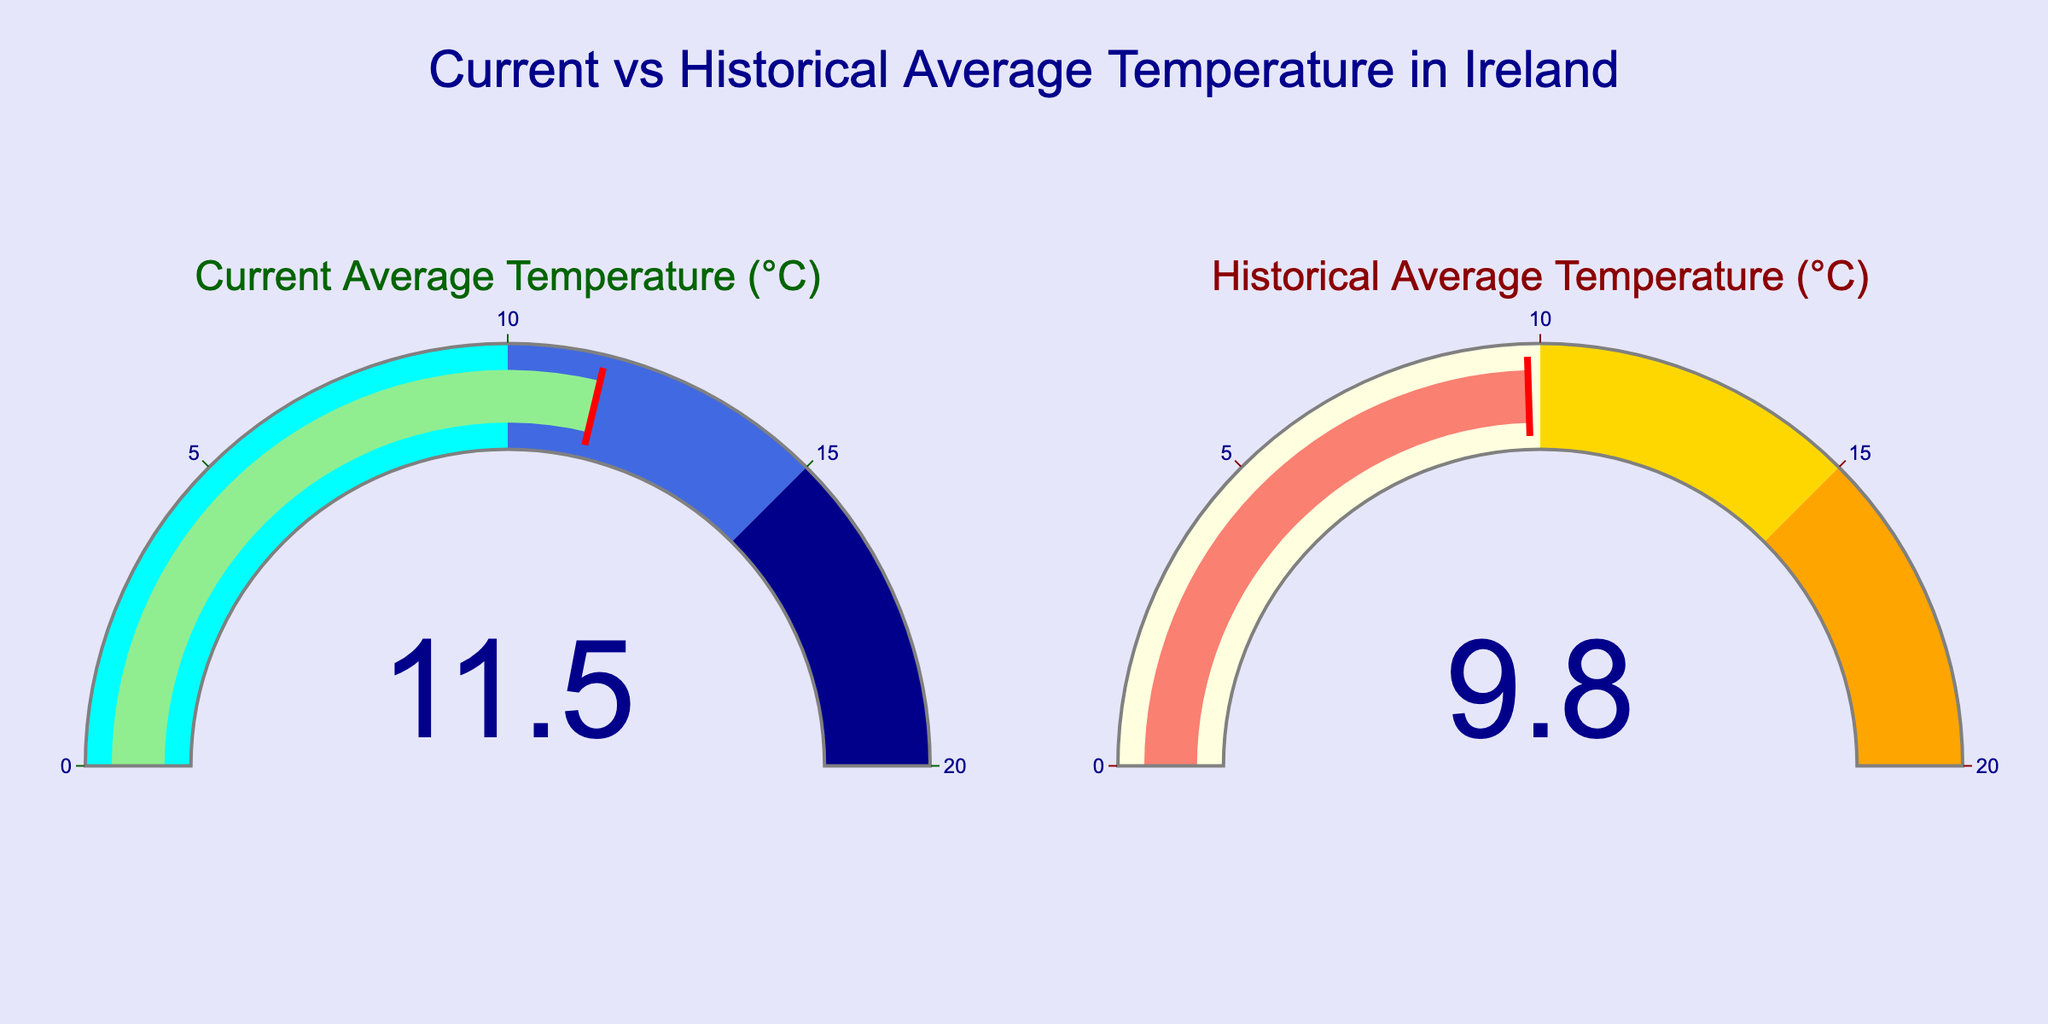How much higher is the current average temperature compared to the historical average temperature? Subtract the historical average temperature (9.8°C) from the current average temperature (11.5°C): 11.5 - 9.8 = 1.7°C.
Answer: 1.7°C What is the title of the figure? Read the title located at the top-center of the figure: "Current vs Historical Average Temperature in Ireland".
Answer: Current vs Historical Average Temperature in Ireland What colors are used to represent the current and historical average temperatures on the gauges? The current average temperature uses light green for the bar and colors like cyan, royal blue, and dark blue for the gauge steps. The historical average temperature uses salmon for the bar and colors like light yellow, gold, and orange for the gauge steps.
Answer: Light green and salmon for bars; cyan, royal blue, dark blue, light yellow, gold, and orange for steps Which gauge has a higher value? Compare the numbers displayed in both gauges. The current average temperature gauge shows 11.5°C, which is higher than the historical average temperature gauge showing 9.8°C.
Answer: Current average temperature gauge What is the threshold value in both gauges? The threshold value in both gauges is indicated by a red line at the value of each gauge. The current average temperature gauge has a threshold value at 11.5°C, and the historical average temperature gauge has a threshold value at 9.8°C.
Answer: 11.5°C for current, 9.8°C for historical Is the current average temperature above 10°C? Look at the value in the current average temperature gauge, which is 11.5°C, and determine if it is above 10°C.
Answer: Yes Are both average temperatures within the range of the gauge axes? The gauge axes range from 0 to 20°C. Both the current average temperature (11.5°C) and historical average temperature (9.8°C) are within this range.
Answer: Yes What's the difference in temperature between the current and historical values? Subtract the historical average temperature (9.8°C) from the current average temperature (11.5°C) to find the difference: 11.5 - 9.8 = 1.7°C.
Answer: 1.7°C Does the historical average temperature fall into the range where the gauge color is gold? The gold range on the historical average temperature gauge is from 10 to 15°C. The historical average temperature is 9.8°C, which falls in the light yellow range (0 to 10°C).
Answer: No Which temperature gauge has more steps within its range? Both the current and historical average temperature gauges have three steps in their range, so neither has more steps than the other.
Answer: Equal number of steps 